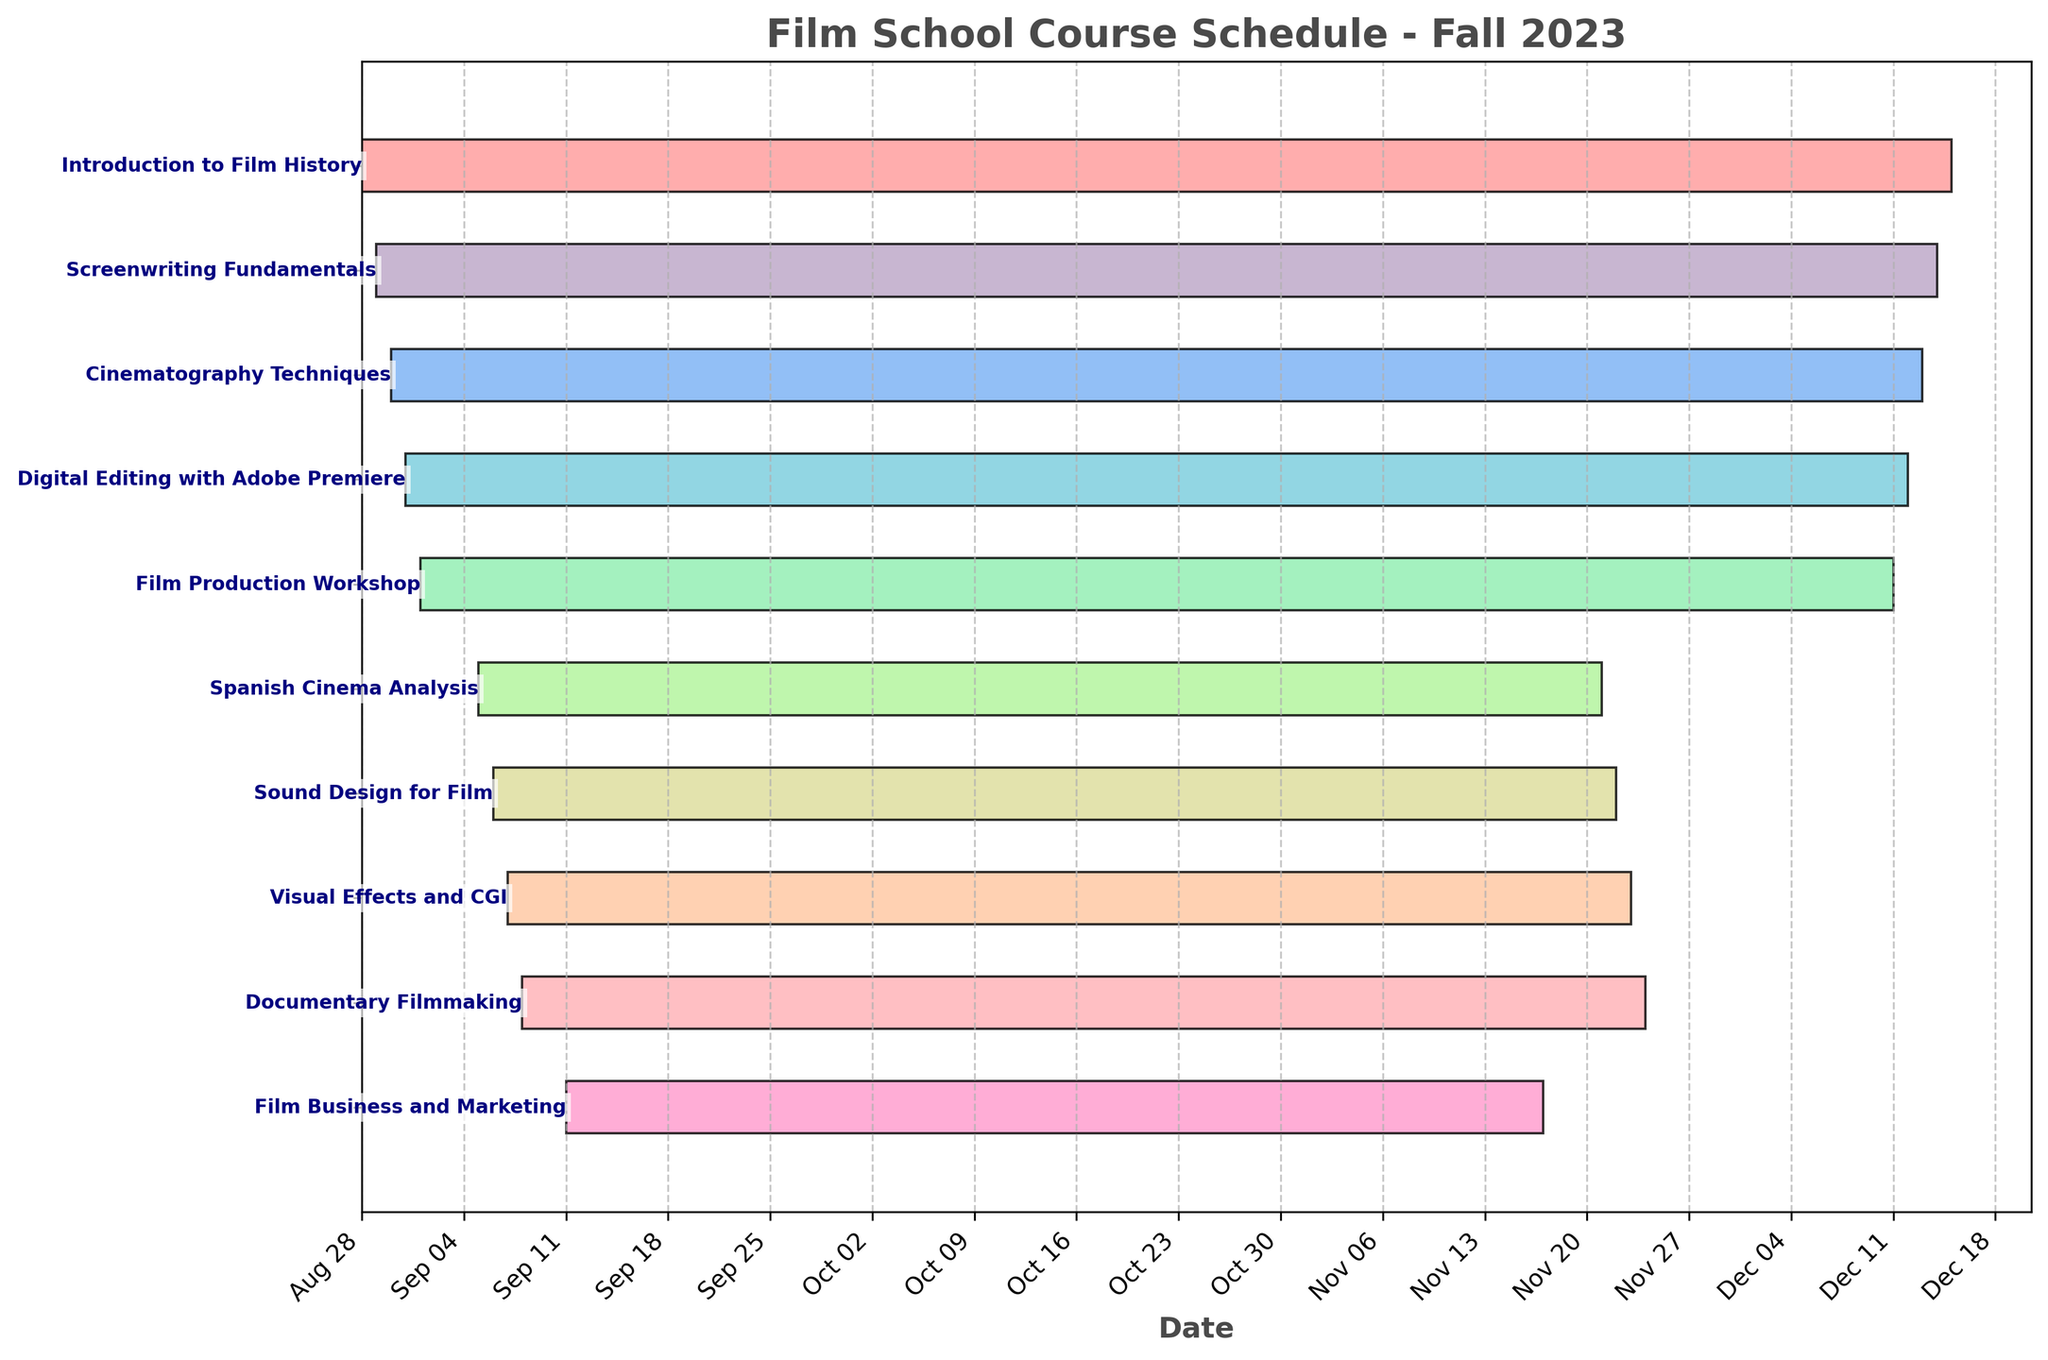What is the title of the Gantt Chart? The title is found at the top of the chart, usually in a larger font and bolded text.
Answer: Film School Course Schedule - Fall 2023 How many courses are displayed in the Gantt Chart? Count the number of rows/bars in the chart, each representing a course.
Answer: 10 Which course ends the earliest? Identify the course with the bar that extends the shortest to the right.
Answer: Film Business and Marketing Between which two dates does the Digital Editing with Adobe Premiere class run? Locate the bar for Digital Editing with Adobe Premiere and note its start and end points on the horizontal axis.
Answer: August 31 to December 12 Which course has the longest duration? Compare the lengths of all the bars and identify the longest one.
Answer: Introduction to Film History Which courses overlap with the Spanish Cinema Analysis course? Identify the time span of Spanish Cinema Analysis and visually check which other courses have bars that overlap with this span.
Answer: Sound Design for Film, Visual Effects and CGI, Documentary Filmmaking, Film Business and Marketing How many weeks does the Cinematography Techniques course run? Determine the start and end dates of the Cinematography Techniques course, compute the duration in days, and convert to weeks.
Answer: Approximately 16 weeks Which courses begin in September? Check the start dates of all courses and select those that begin in the month of September.
Answer: Film Production Workshop, Spanish Cinema Analysis, Sound Design for Film, Visual Effects and CGI, Documentary Filmmaking, Film Business and Marketing What is the duration of the Sound Design for Film course? Calculate the number of days between the start and end dates of the Sound Design for Film course.
Answer: 77 days Do any courses finish in November? If yes, which ones? Check the end dates of all courses and identify those that end in November.
Answer: Sound Design for Film, Visual Effects and CGI, Documentary Filmmaking, Film Business and Marketing 